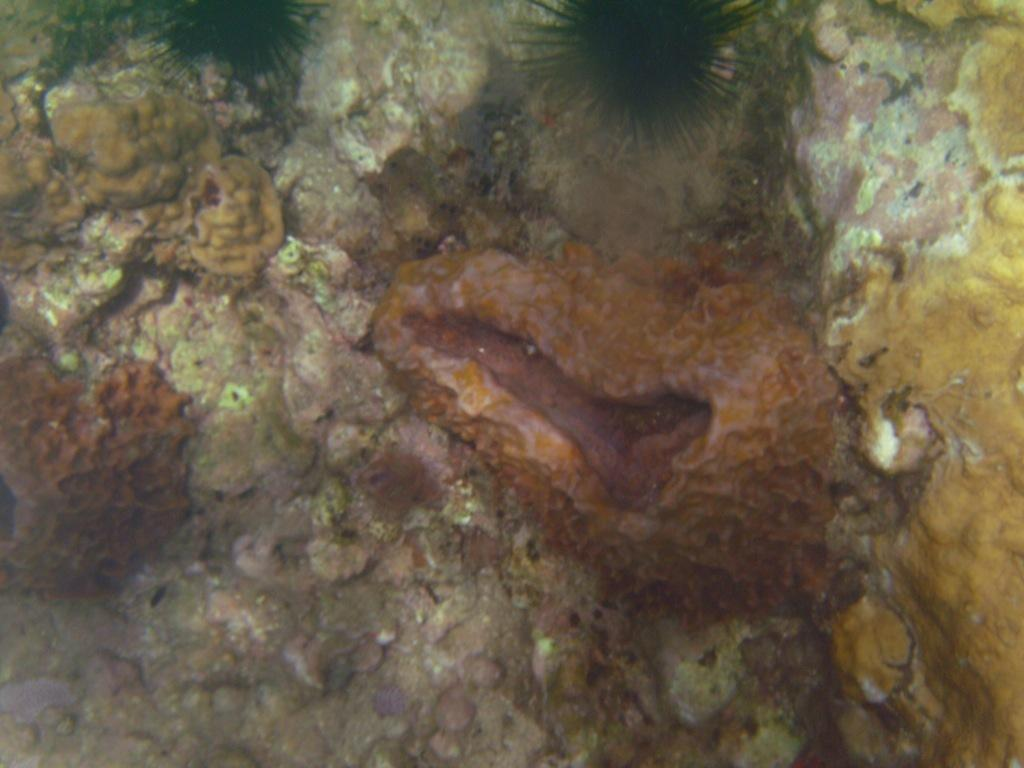What is the main subject in the center of the image? There are corals and stones in the center of the image. Can you describe any other objects present in the center of the image? Yes, there are a few other objects in the center of the image. How many eyes can be seen on the corals in the image? There are no eyes visible on the corals in the image, as corals are marine invertebrates and do not have eyes. 